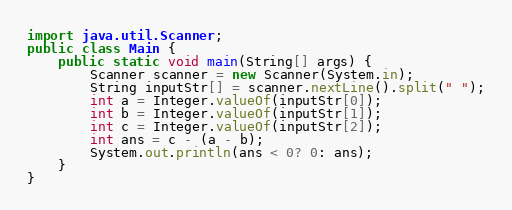Convert code to text. <code><loc_0><loc_0><loc_500><loc_500><_Java_>import java.util.Scanner;
public class Main {
    public static void main(String[] args) {
        Scanner scanner = new Scanner(System.in);
        String inputStr[] = scanner.nextLine().split(" ");
        int a = Integer.valueOf(inputStr[0]);
        int b = Integer.valueOf(inputStr[1]);
        int c = Integer.valueOf(inputStr[2]);
        int ans = c - (a - b);
        System.out.println(ans < 0? 0: ans);
    }
}</code> 